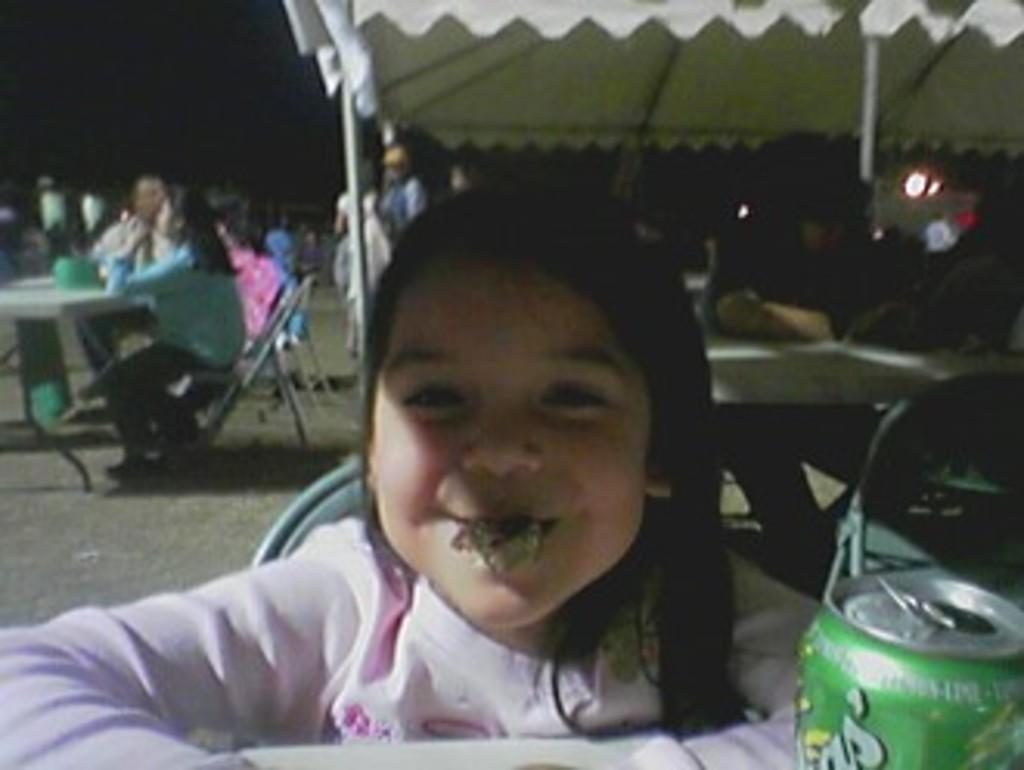Can you describe this image briefly? Here we can see a girl sitting on the chair and there is a tin. There are few persons sitting on the chairs. Here we can see tables, chairs, poles, lights, and a tent. There is a dark background. 